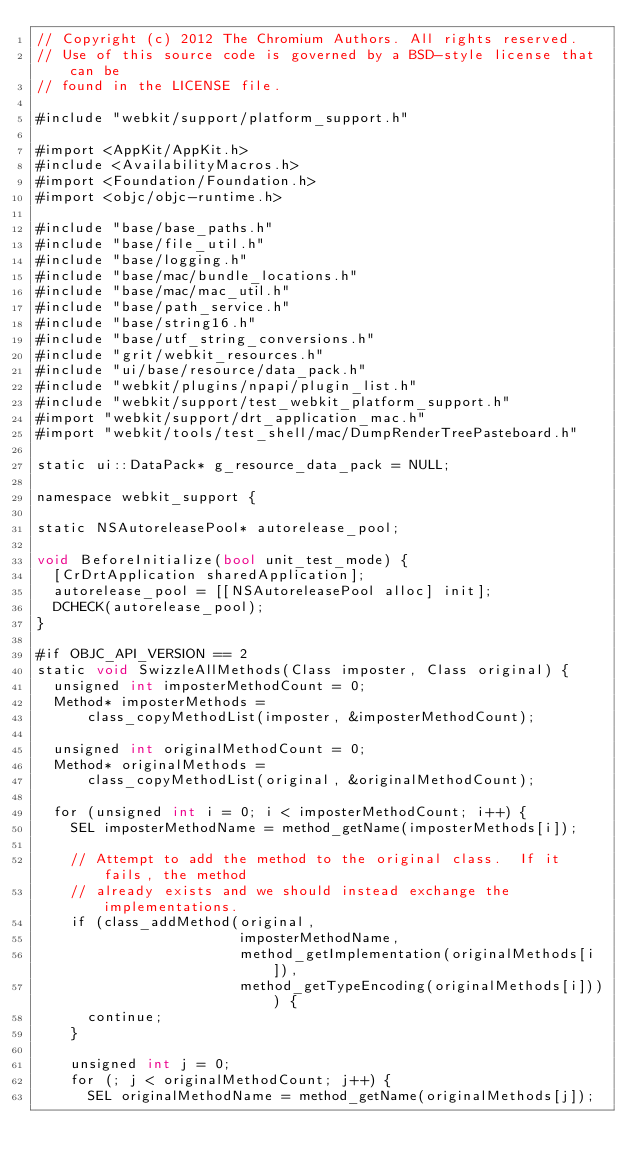Convert code to text. <code><loc_0><loc_0><loc_500><loc_500><_ObjectiveC_>// Copyright (c) 2012 The Chromium Authors. All rights reserved.
// Use of this source code is governed by a BSD-style license that can be
// found in the LICENSE file.

#include "webkit/support/platform_support.h"

#import <AppKit/AppKit.h>
#include <AvailabilityMacros.h>
#import <Foundation/Foundation.h>
#import <objc/objc-runtime.h>

#include "base/base_paths.h"
#include "base/file_util.h"
#include "base/logging.h"
#include "base/mac/bundle_locations.h"
#include "base/mac/mac_util.h"
#include "base/path_service.h"
#include "base/string16.h"
#include "base/utf_string_conversions.h"
#include "grit/webkit_resources.h"
#include "ui/base/resource/data_pack.h"
#include "webkit/plugins/npapi/plugin_list.h"
#include "webkit/support/test_webkit_platform_support.h"
#import "webkit/support/drt_application_mac.h"
#import "webkit/tools/test_shell/mac/DumpRenderTreePasteboard.h"

static ui::DataPack* g_resource_data_pack = NULL;

namespace webkit_support {

static NSAutoreleasePool* autorelease_pool;

void BeforeInitialize(bool unit_test_mode) {
  [CrDrtApplication sharedApplication];
  autorelease_pool = [[NSAutoreleasePool alloc] init];
  DCHECK(autorelease_pool);
}

#if OBJC_API_VERSION == 2
static void SwizzleAllMethods(Class imposter, Class original) {
  unsigned int imposterMethodCount = 0;
  Method* imposterMethods =
      class_copyMethodList(imposter, &imposterMethodCount);

  unsigned int originalMethodCount = 0;
  Method* originalMethods =
      class_copyMethodList(original, &originalMethodCount);

  for (unsigned int i = 0; i < imposterMethodCount; i++) {
    SEL imposterMethodName = method_getName(imposterMethods[i]);

    // Attempt to add the method to the original class.  If it fails, the method
    // already exists and we should instead exchange the implementations.
    if (class_addMethod(original,
                        imposterMethodName,
                        method_getImplementation(originalMethods[i]),
                        method_getTypeEncoding(originalMethods[i]))) {
      continue;
    }

    unsigned int j = 0;
    for (; j < originalMethodCount; j++) {
      SEL originalMethodName = method_getName(originalMethods[j]);</code> 